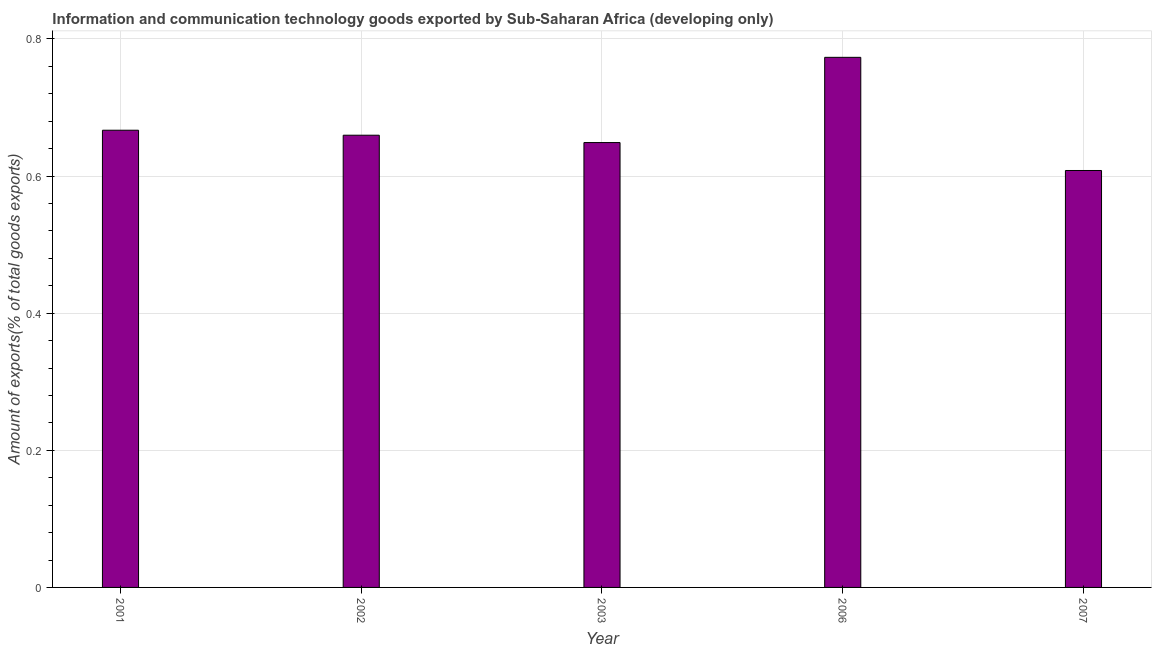What is the title of the graph?
Provide a succinct answer. Information and communication technology goods exported by Sub-Saharan Africa (developing only). What is the label or title of the X-axis?
Offer a terse response. Year. What is the label or title of the Y-axis?
Provide a succinct answer. Amount of exports(% of total goods exports). What is the amount of ict goods exports in 2007?
Give a very brief answer. 0.61. Across all years, what is the maximum amount of ict goods exports?
Provide a succinct answer. 0.77. Across all years, what is the minimum amount of ict goods exports?
Your answer should be compact. 0.61. In which year was the amount of ict goods exports maximum?
Make the answer very short. 2006. What is the sum of the amount of ict goods exports?
Your answer should be compact. 3.36. What is the difference between the amount of ict goods exports in 2002 and 2007?
Keep it short and to the point. 0.05. What is the average amount of ict goods exports per year?
Make the answer very short. 0.67. What is the median amount of ict goods exports?
Your response must be concise. 0.66. Do a majority of the years between 2002 and 2007 (inclusive) have amount of ict goods exports greater than 0.04 %?
Your answer should be compact. Yes. What is the ratio of the amount of ict goods exports in 2001 to that in 2003?
Give a very brief answer. 1.03. Is the amount of ict goods exports in 2001 less than that in 2007?
Ensure brevity in your answer.  No. What is the difference between the highest and the second highest amount of ict goods exports?
Offer a terse response. 0.11. Is the sum of the amount of ict goods exports in 2001 and 2007 greater than the maximum amount of ict goods exports across all years?
Your answer should be compact. Yes. What is the difference between the highest and the lowest amount of ict goods exports?
Your answer should be very brief. 0.17. In how many years, is the amount of ict goods exports greater than the average amount of ict goods exports taken over all years?
Provide a succinct answer. 1. Are all the bars in the graph horizontal?
Your answer should be compact. No. What is the difference between two consecutive major ticks on the Y-axis?
Provide a short and direct response. 0.2. Are the values on the major ticks of Y-axis written in scientific E-notation?
Give a very brief answer. No. What is the Amount of exports(% of total goods exports) of 2001?
Offer a terse response. 0.67. What is the Amount of exports(% of total goods exports) in 2002?
Keep it short and to the point. 0.66. What is the Amount of exports(% of total goods exports) of 2003?
Give a very brief answer. 0.65. What is the Amount of exports(% of total goods exports) of 2006?
Offer a very short reply. 0.77. What is the Amount of exports(% of total goods exports) of 2007?
Provide a succinct answer. 0.61. What is the difference between the Amount of exports(% of total goods exports) in 2001 and 2002?
Provide a short and direct response. 0.01. What is the difference between the Amount of exports(% of total goods exports) in 2001 and 2003?
Your answer should be very brief. 0.02. What is the difference between the Amount of exports(% of total goods exports) in 2001 and 2006?
Keep it short and to the point. -0.11. What is the difference between the Amount of exports(% of total goods exports) in 2001 and 2007?
Ensure brevity in your answer.  0.06. What is the difference between the Amount of exports(% of total goods exports) in 2002 and 2003?
Ensure brevity in your answer.  0.01. What is the difference between the Amount of exports(% of total goods exports) in 2002 and 2006?
Make the answer very short. -0.11. What is the difference between the Amount of exports(% of total goods exports) in 2002 and 2007?
Provide a short and direct response. 0.05. What is the difference between the Amount of exports(% of total goods exports) in 2003 and 2006?
Provide a succinct answer. -0.12. What is the difference between the Amount of exports(% of total goods exports) in 2003 and 2007?
Provide a short and direct response. 0.04. What is the difference between the Amount of exports(% of total goods exports) in 2006 and 2007?
Your answer should be very brief. 0.17. What is the ratio of the Amount of exports(% of total goods exports) in 2001 to that in 2002?
Provide a short and direct response. 1.01. What is the ratio of the Amount of exports(% of total goods exports) in 2001 to that in 2003?
Keep it short and to the point. 1.03. What is the ratio of the Amount of exports(% of total goods exports) in 2001 to that in 2006?
Make the answer very short. 0.86. What is the ratio of the Amount of exports(% of total goods exports) in 2001 to that in 2007?
Provide a succinct answer. 1.1. What is the ratio of the Amount of exports(% of total goods exports) in 2002 to that in 2006?
Make the answer very short. 0.85. What is the ratio of the Amount of exports(% of total goods exports) in 2002 to that in 2007?
Keep it short and to the point. 1.08. What is the ratio of the Amount of exports(% of total goods exports) in 2003 to that in 2006?
Keep it short and to the point. 0.84. What is the ratio of the Amount of exports(% of total goods exports) in 2003 to that in 2007?
Offer a very short reply. 1.07. What is the ratio of the Amount of exports(% of total goods exports) in 2006 to that in 2007?
Make the answer very short. 1.27. 